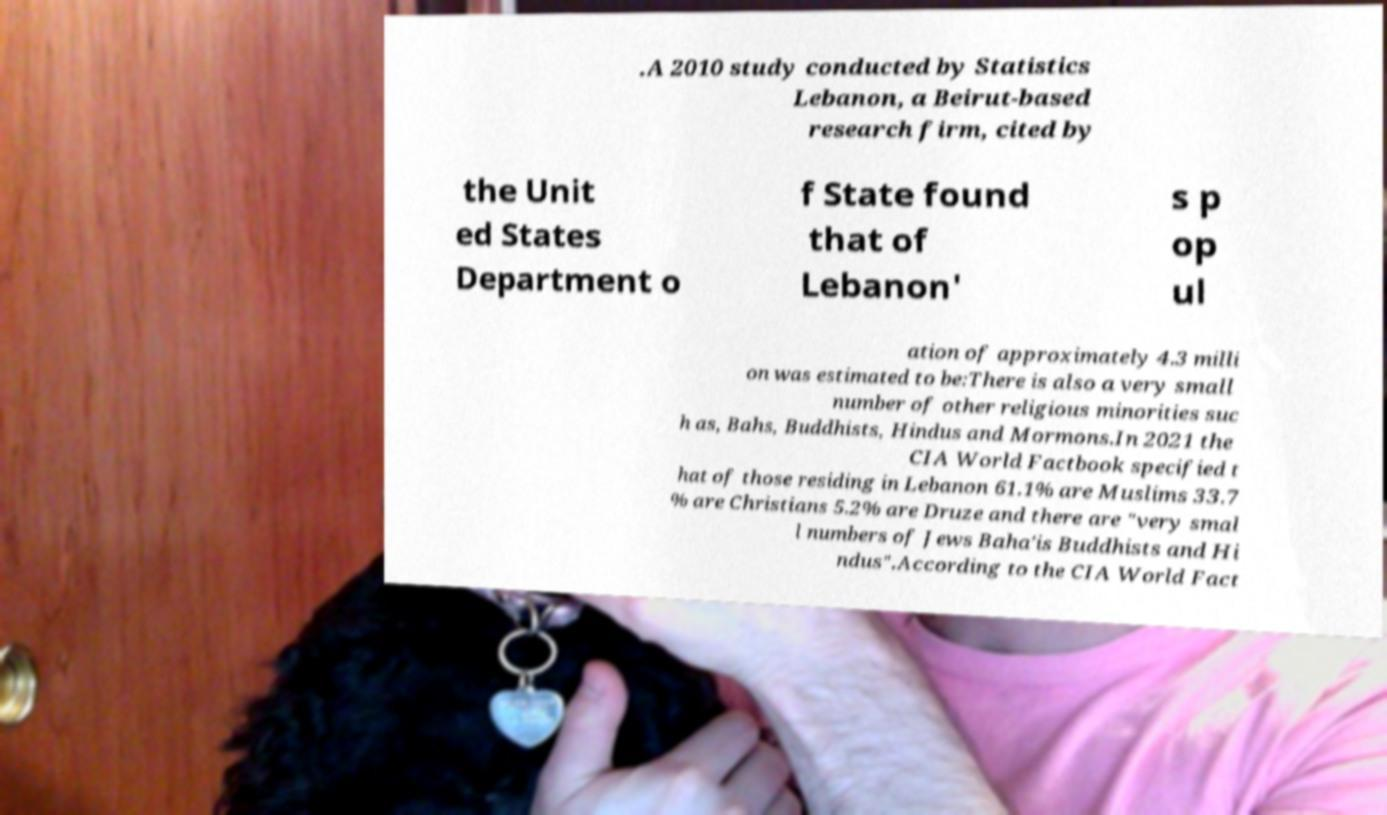Could you extract and type out the text from this image? .A 2010 study conducted by Statistics Lebanon, a Beirut-based research firm, cited by the Unit ed States Department o f State found that of Lebanon' s p op ul ation of approximately 4.3 milli on was estimated to be:There is also a very small number of other religious minorities suc h as, Bahs, Buddhists, Hindus and Mormons.In 2021 the CIA World Factbook specified t hat of those residing in Lebanon 61.1% are Muslims 33.7 % are Christians 5.2% are Druze and there are "very smal l numbers of Jews Baha'is Buddhists and Hi ndus".According to the CIA World Fact 